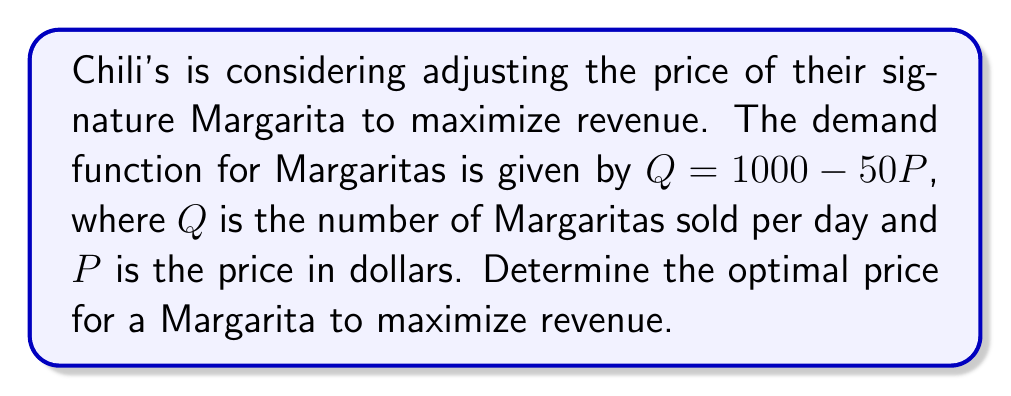Can you solve this math problem? 1. The revenue function $R(P)$ is given by price times quantity:
   $R(P) = P \cdot Q = P(1000 - 50P) = 1000P - 50P^2$

2. To find the maximum revenue, we need to find the derivative of $R(P)$ and set it equal to zero:
   $$\frac{dR}{dP} = 1000 - 100P$$

3. Set the derivative equal to zero and solve for $P$:
   $$1000 - 100P = 0$$
   $$100P = 1000$$
   $$P = 10$$

4. To confirm this is a maximum, we can check the second derivative:
   $$\frac{d^2R}{dP^2} = -100$$
   Since this is negative, we confirm that $P = 10$ gives a maximum.

5. Therefore, the optimal price for a Margarita to maximize revenue is $10.

6. We can calculate the maximum revenue:
   $R(10) = 1000(10) - 50(10^2) = 10000 - 5000 = 5000$

So, the maximum daily revenue from Margaritas would be $5000 at a price of $10 each.
Answer: $10 